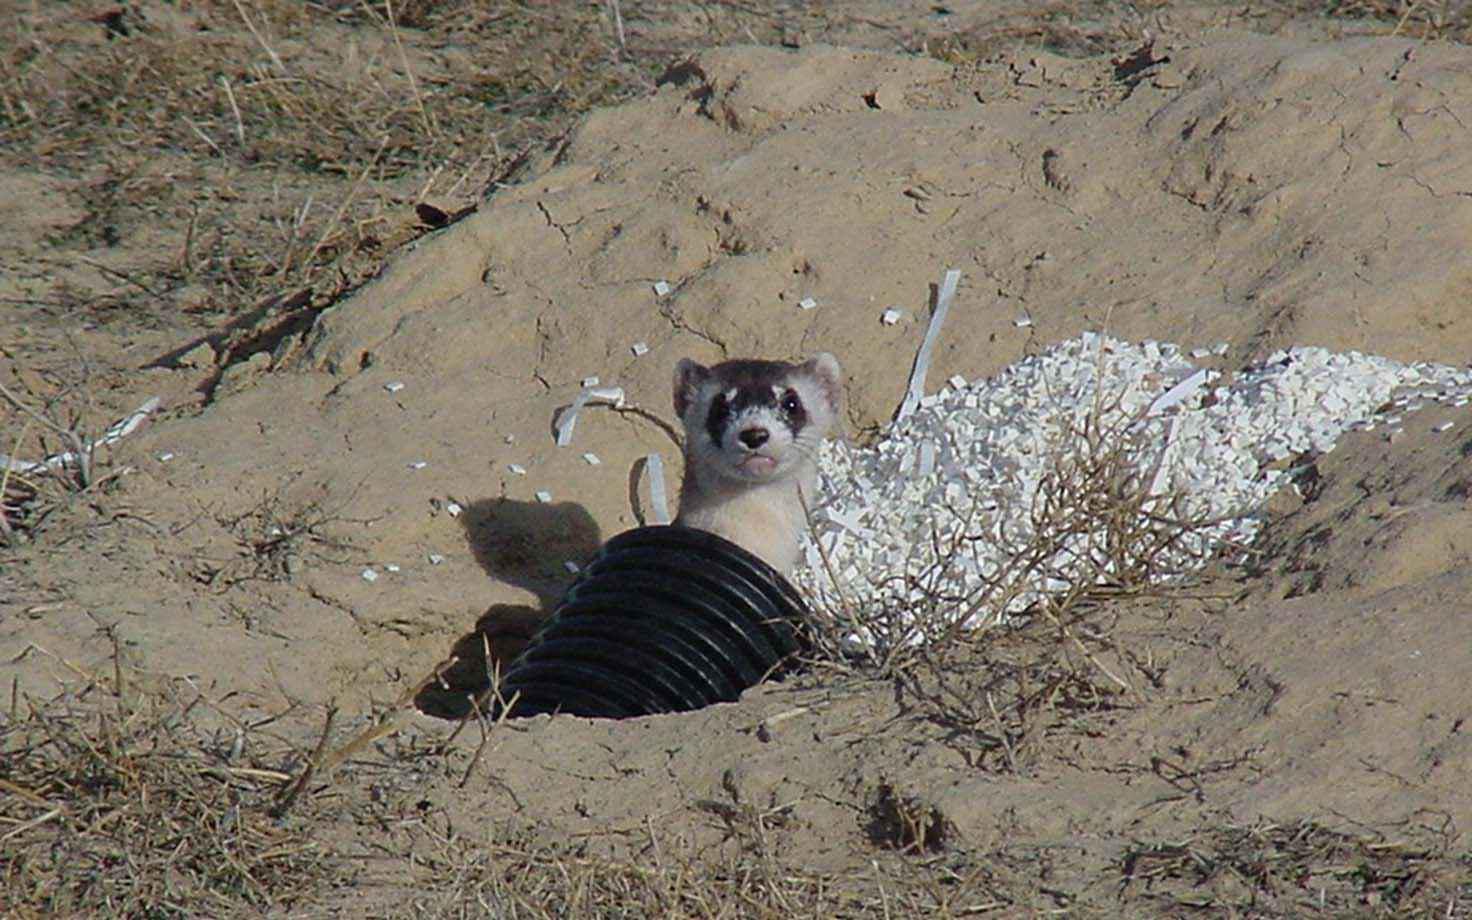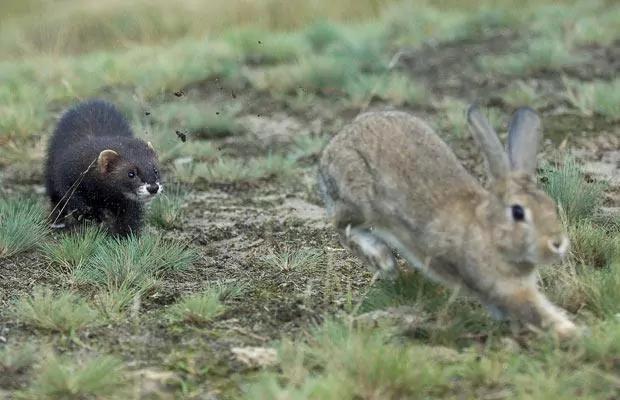The first image is the image on the left, the second image is the image on the right. Analyze the images presented: Is the assertion "Right image shows a ferret pursuing a different breed of animal outdoors." valid? Answer yes or no. Yes. The first image is the image on the left, the second image is the image on the right. For the images shown, is this caption "There are exactly two animals in the image on the left." true? Answer yes or no. No. 